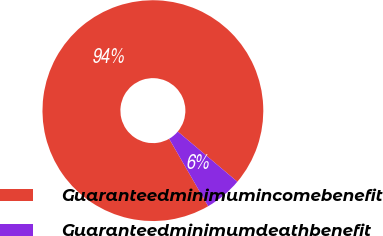Convert chart. <chart><loc_0><loc_0><loc_500><loc_500><pie_chart><fcel>Guaranteedminimumincomebenefit<fcel>Guaranteedminimumdeathbenefit<nl><fcel>94.48%<fcel>5.52%<nl></chart> 